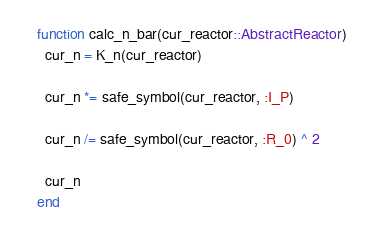<code> <loc_0><loc_0><loc_500><loc_500><_Julia_>function calc_n_bar(cur_reactor::AbstractReactor)
  cur_n = K_n(cur_reactor)

  cur_n *= safe_symbol(cur_reactor, :I_P)

  cur_n /= safe_symbol(cur_reactor, :R_0) ^ 2

  cur_n
end
</code> 